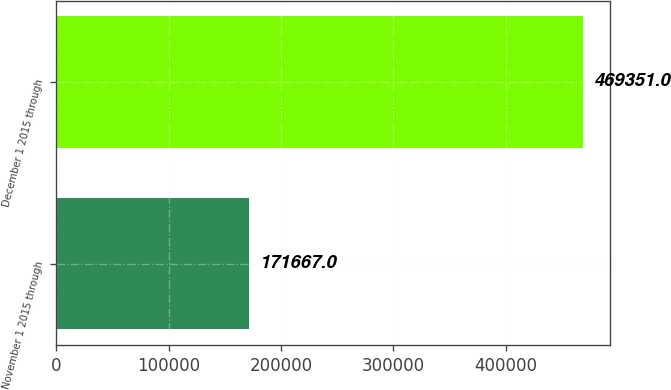Convert chart. <chart><loc_0><loc_0><loc_500><loc_500><bar_chart><fcel>November 1 2015 through<fcel>December 1 2015 through<nl><fcel>171667<fcel>469351<nl></chart> 